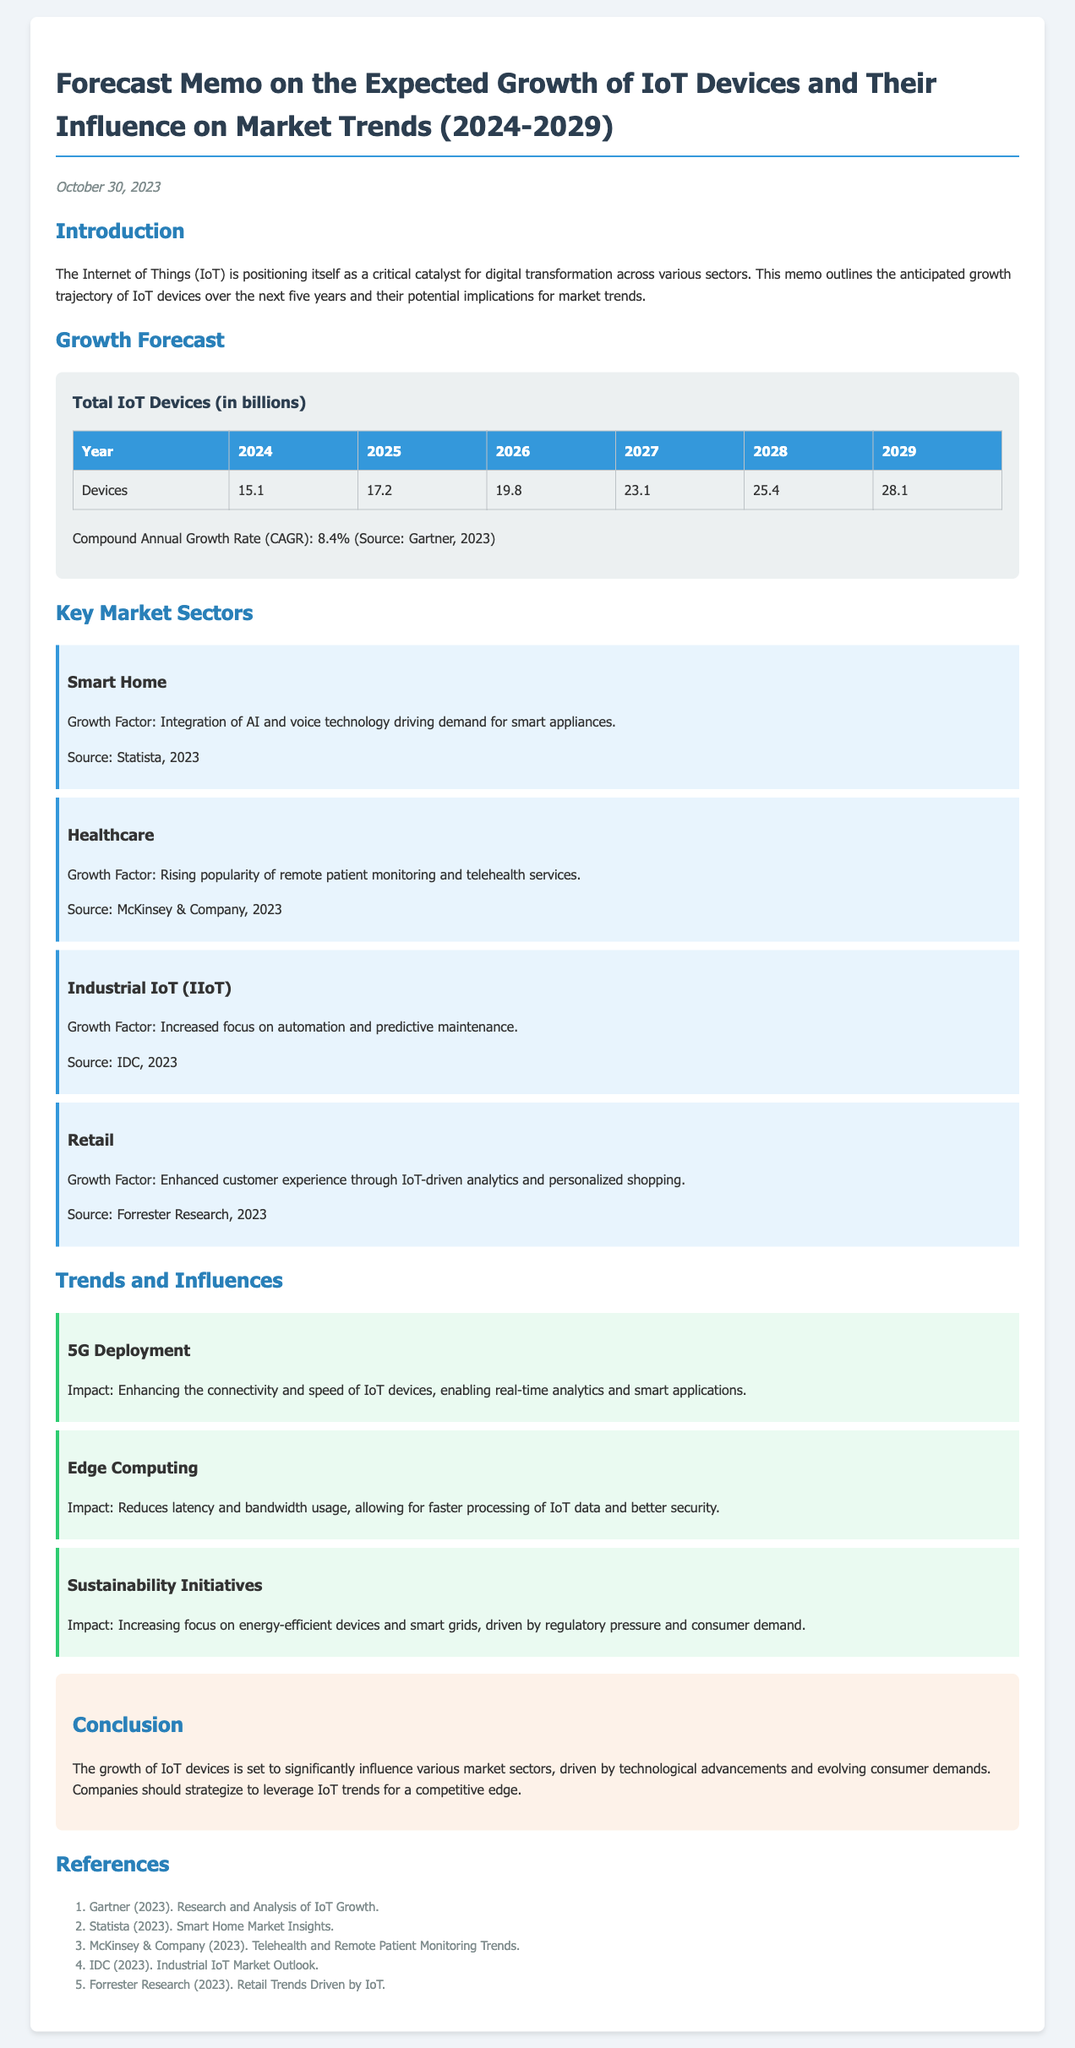What is the total number of IoT devices expected in 2026? The document states that the projected number of IoT devices in 2026 is 19.8 billion.
Answer: 19.8 billion What is the compound annual growth rate (CAGR) mentioned? The CAGR provided in the memo is 8.4%.
Answer: 8.4% Which sector is expected to see growth due to remote patient monitoring? The healthcare sector is highlighted for its growth in remote patient monitoring and telehealth services.
Answer: Healthcare What technology enhances connectivity for IoT devices? The document mentions 5G deployment as a key technology improving IoT connectivity.
Answer: 5G What is a key factor driving growth in the smart home sector? The integration of AI and voice technology is cited as a growth factor in the smart home sector.
Answer: AI and voice technology In which year is the total number of IoT devices expected to first exceed 25 billion? According to the table, the total number of IoT devices is expected to exceed 25 billion in 2028.
Answer: 2028 What is the purpose of edge computing in the context of IoT? The role of edge computing is to reduce latency and bandwidth usage for faster IoT data processing.
Answer: Reduce latency and bandwidth usage Which organization provided insights into the smart home market? Statista is indicated as the source for insights on the smart home market.
Answer: Statista 